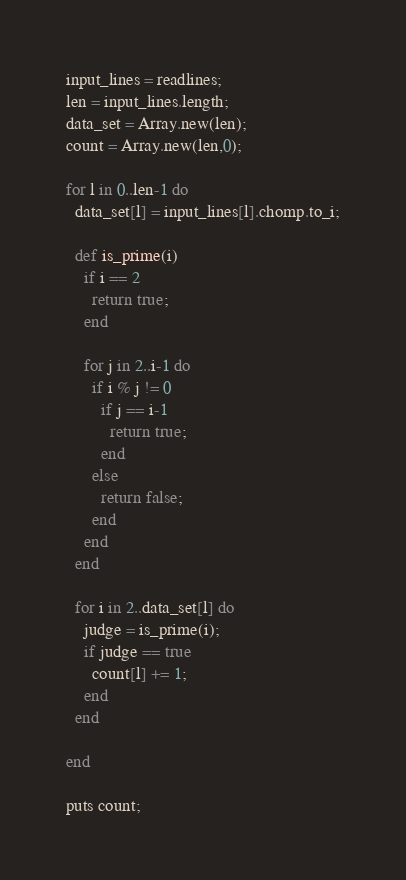Convert code to text. <code><loc_0><loc_0><loc_500><loc_500><_Ruby_>input_lines = readlines;
len = input_lines.length;
data_set = Array.new(len);
count = Array.new(len,0);

for l in 0..len-1 do
  data_set[l] = input_lines[l].chomp.to_i;

  def is_prime(i)
    if i == 2
      return true;
    end

    for j in 2..i-1 do
      if i % j != 0
        if j == i-1
          return true;
        end
      else
        return false;
      end
    end
  end

  for i in 2..data_set[l] do
    judge = is_prime(i);
    if judge == true
      count[l] += 1;
    end
  end

end

puts count;
</code> 